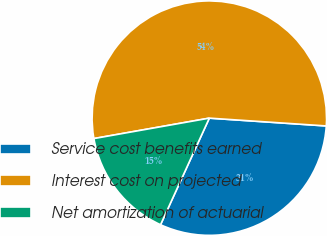Convert chart to OTSL. <chart><loc_0><loc_0><loc_500><loc_500><pie_chart><fcel>Service cost benefits earned<fcel>Interest cost on projected<fcel>Net amortization of actuarial<nl><fcel>30.77%<fcel>53.85%<fcel>15.38%<nl></chart> 